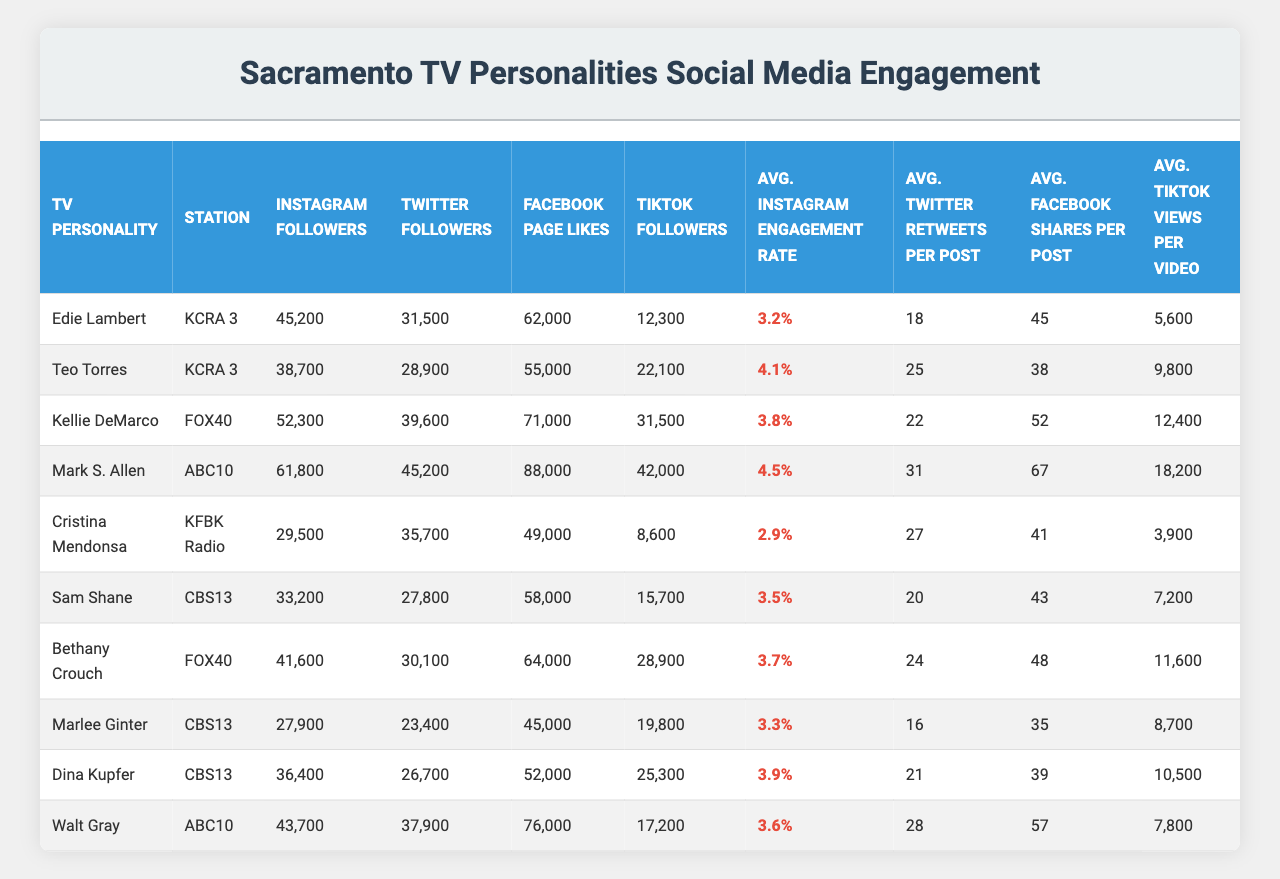What is the station of Edie Lambert? The table shows that Edie Lambert is associated with KCRA 3.
Answer: KCRA 3 Who has the highest number of Instagram followers? Comparing the Instagram followers of all personalities, Mark S. Allen has the highest with 61,800 followers.
Answer: Mark S. Allen What is the average engagement rate on Instagram for the TV personalities? To find the average engagement rate, we sum the engagement rates of all personalities (3.2%, 4.1%, 3.8%, 4.5%, 2.9%, 3.5%, 3.7%, 3.3%, 3.9%, 3.6%) which equals 38.5%, and then divide by the number of personalities (10), yielding an average of 3.85%.
Answer: 3.85% Is it true that Cristina Mendonsa has more Facebook Page Likes than Edie Lambert? Cristina Mendonsa has 49,000 Facebook Page Likes, while Edie Lambert has 62,000, so this statement is false.
Answer: No How many more TikTok followers does Teo Torres have compared to Sam Shane? Teo Torres has 22,100 TikTok followers, and Sam Shane has 15,700. The difference is 22,100 - 15,700 = 6,400.
Answer: 6,400 Which TV personality has the highest average Twitter retweets per post? By reviewing the averages, Mark S. Allen has the highest at 31 retweets per post.
Answer: Mark S. Allen What is the average number of Facebook shares per post for all personalities? The total number of shares is (45 + 38 + 52 + 67 + 41 + 43 + 48 + 35 + 39 + 57), summing to 462, and dividing by 10 yields an average of 46.2 shares.
Answer: 46.2 Who is the second highest on TikTok followers after Mark S. Allen? After Mark S. Allen, Teo Torres has the next highest TikTok followers at 22,100.
Answer: Teo Torres Which personality has the lowest engagement rate on Instagram? The lowest engagement rate from the table is Cristina Mendonsa with 2.9%.
Answer: Cristina Mendonsa If we sum the Instagram followers of all personalities, what is the total? The total is the sum of Instagram followers (45,200 + 38,700 + 52,300 + 61,800 + 29,500 + 33,200 + 41,600 + 27,900 + 36,400 + 43,700), which equals 410,300.
Answer: 410,300 